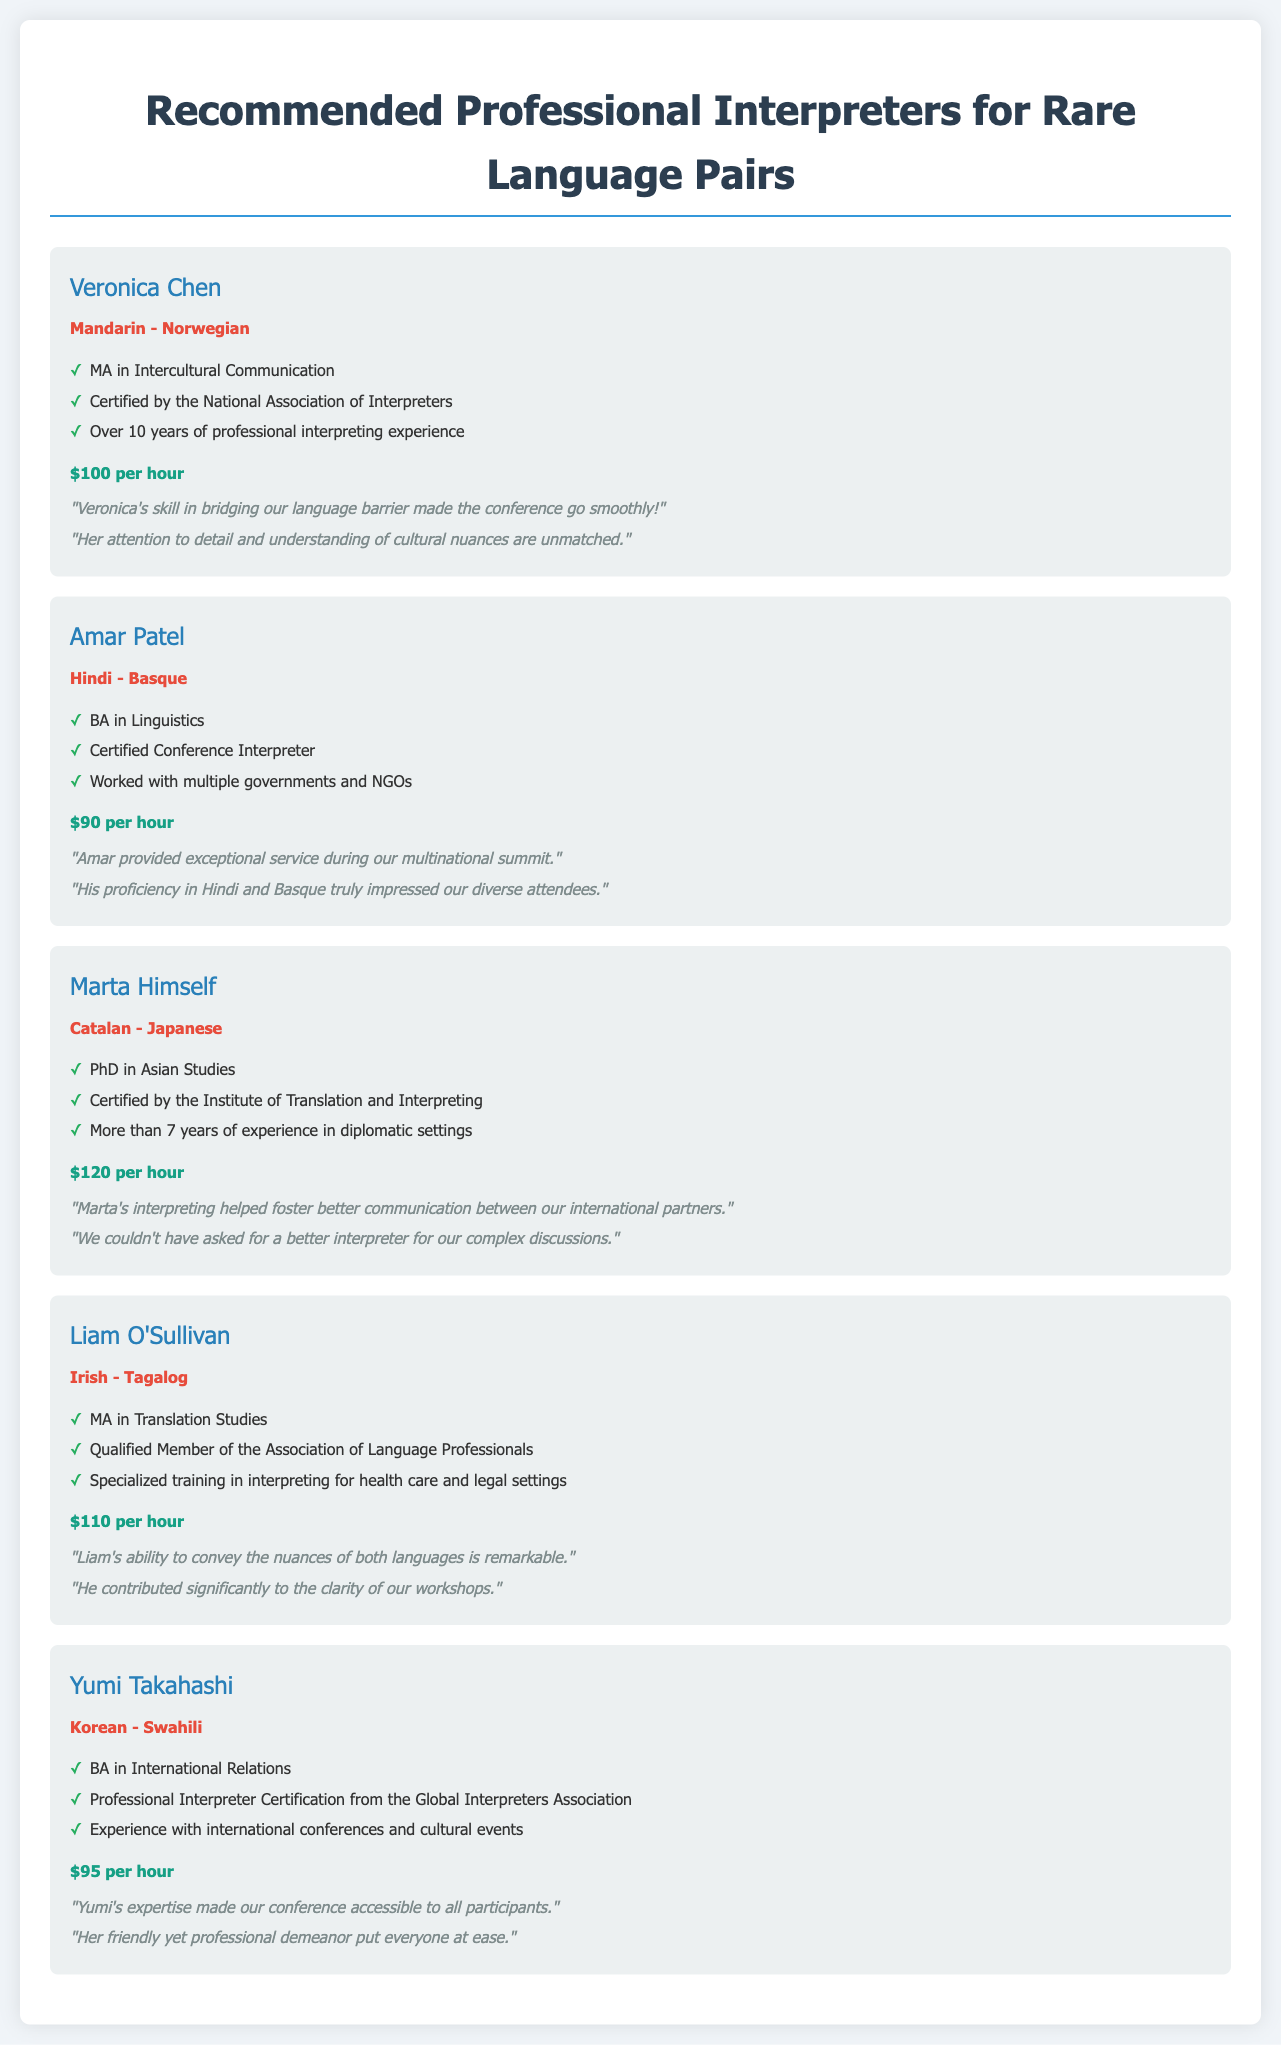What is Veronica Chen's language pair? Veronica Chen's language pair is specifically mentioned in her interpreter card as Mandarin - Norwegian.
Answer: Mandarin - Norwegian What is the hourly rate for Amar Patel? Amar Patel's hourly rate is stated clearly in his interpreter card.
Answer: $90 per hour How many years of experience does Marta Himself have? Marta Himself has more than 7 years of experience, as indicated in her card.
Answer: More than 7 years Which interpreter has a qualification in International Relations? The qualification in International Relations belongs to Yumi Takahashi, as per her profile.
Answer: Yumi Takahashi What is the qualification of Liam O'Sullivan? The qualification of Liam O'Sullivan is listed as MA in Translation Studies in his interpreter card.
Answer: MA in Translation Studies Which language pair is associated with Yumi Takahashi? Yumi Takahashi's language pair is explicitly noted in her card.
Answer: Korean - Swahili Who provided "exceptional service during our multinational summit"? The testimonial specifically mentioning exceptional service is referring to Amar Patel.
Answer: Amar Patel What is the testimonial for Veronica Chen regarding her skills? The testimonial for Veronica Chen mentions her skill in bridging language barriers during the conference.
Answer: "Veronica's skill in bridging our language barrier made the conference go smoothly!" 